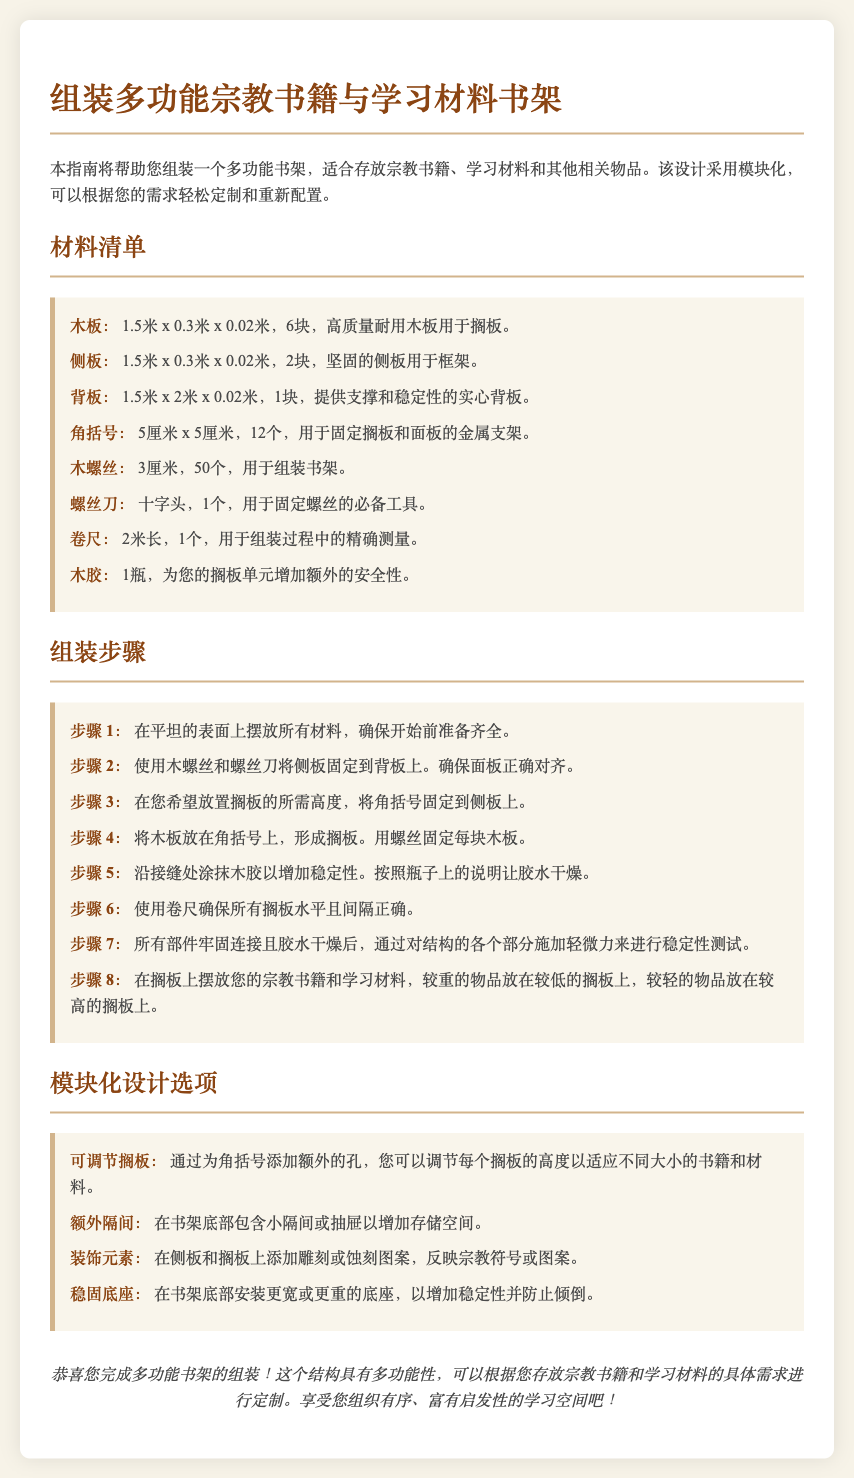What size are the wooden boards? The size of the wooden boards listed in the materials list is 1.5米 x 0.3米 x 0.02米.
Answer: 1.5米 x 0.3米 x 0.02米 How many side panels are required? The materials list specifies that 2 side panels are required.
Answer: 2块 What tool is necessary to secure the screws? The instructions mention that a crosshead screwdriver is required for securing the screws.
Answer: 十字头 What is the purpose of wood glue? The instructions indicate that wood glue adds extra security to the shelf units.
Answer: 增加安全性 Which step involves measuring with a measuring tape? Step 6 specifically involves using a measuring tape to ensure all shelves are level and spaced correctly.
Answer: 步骤 6 How many corner brackets are needed? The materials list states that 12 corner brackets are required.
Answer: 12个 What modular design option allows for adjustable shelf heights? The modular design option that allows for adjustable shelf heights is adding extra holes for the corner brackets.
Answer: 可调节搁板 What is suggested for stabilizing the bookshelf? The instructions suggest installing a wider or heavier base at the bottom of the bookshelf for increased stability.
Answer: 稳固底座 